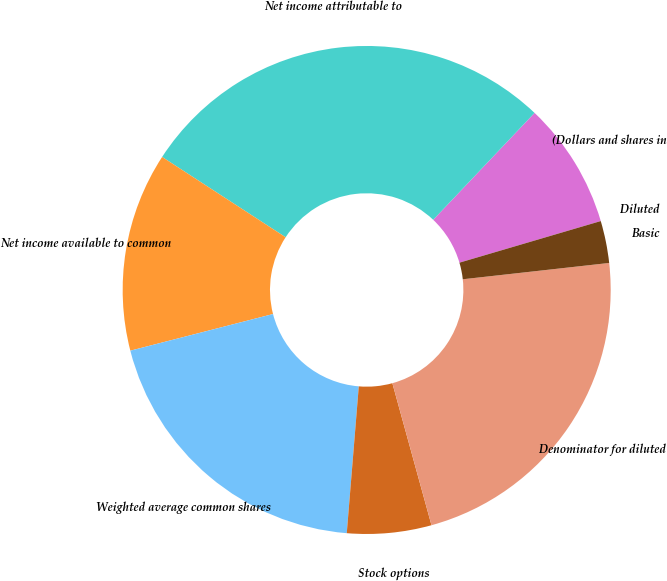Convert chart. <chart><loc_0><loc_0><loc_500><loc_500><pie_chart><fcel>(Dollars and shares in<fcel>Net income attributable to<fcel>Net income available to common<fcel>Weighted average common shares<fcel>Stock options<fcel>Denominator for diluted<fcel>Basic<fcel>Diluted<nl><fcel>8.37%<fcel>27.9%<fcel>13.18%<fcel>19.7%<fcel>5.58%<fcel>22.49%<fcel>2.79%<fcel>0.0%<nl></chart> 